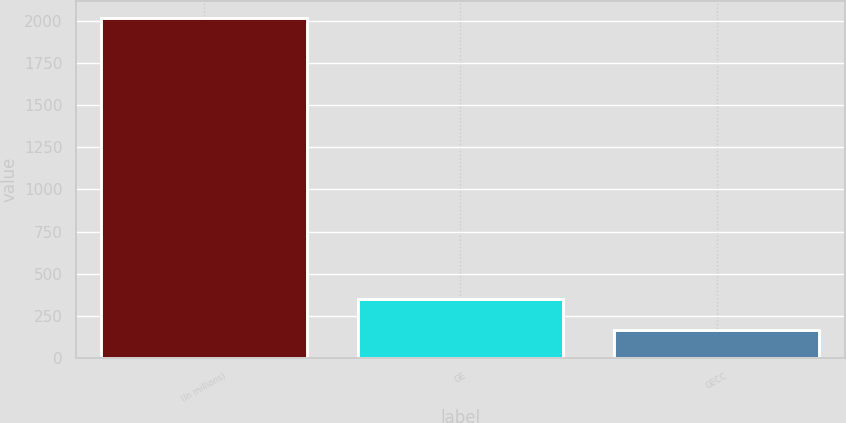Convert chart to OTSL. <chart><loc_0><loc_0><loc_500><loc_500><bar_chart><fcel>(In millions)<fcel>GE<fcel>GECC<nl><fcel>2016<fcel>349.2<fcel>164<nl></chart> 